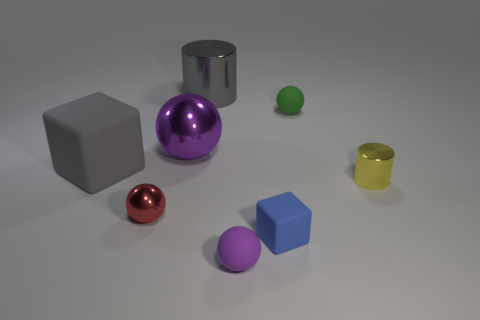Subtract all red balls. Subtract all red cubes. How many balls are left? 3 Add 1 red rubber things. How many objects exist? 9 Subtract all cubes. How many objects are left? 6 Add 5 green rubber spheres. How many green rubber spheres are left? 6 Add 5 brown rubber cubes. How many brown rubber cubes exist? 5 Subtract 1 gray cylinders. How many objects are left? 7 Subtract all red cubes. Subtract all small yellow things. How many objects are left? 7 